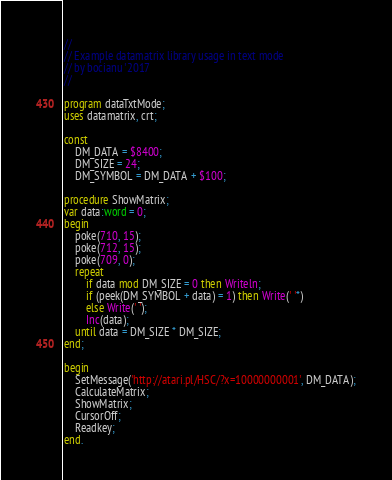Convert code to text. <code><loc_0><loc_0><loc_500><loc_500><_Pascal_>//
// Example datamatrix library usage in text mode
// by bocianu '2017
//

program dataTxtMode;
uses datamatrix, crt;

const
    DM_DATA = $8400;
    DM_SIZE = 24;
    DM_SYMBOL = DM_DATA + $100;

procedure ShowMatrix;
var data:word = 0;
begin
    poke(710, 15);
    poke(712, 15);
    poke(709, 0);
    repeat
        if data mod DM_SIZE = 0 then Writeln;
        if (peek(DM_SYMBOL + data) = 1) then Write(' '*)
        else Write(' ');
        Inc(data);
    until data = DM_SIZE * DM_SIZE;
end;

begin
    SetMessage('http://atari.pl/HSC/?x=10000000001', DM_DATA);
    CalculateMatrix;
    ShowMatrix;
    CursorOff;
    Readkey;
end.
</code> 